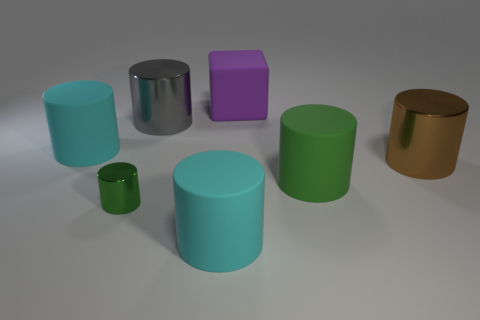Are there any other things that are the same color as the block?
Provide a succinct answer. No. How many green shiny cylinders have the same size as the gray cylinder?
Offer a terse response. 0. There is a object that is the same color as the tiny metal cylinder; what shape is it?
Provide a succinct answer. Cylinder. Do the big matte cylinder left of the tiny metal cylinder and the big shiny thing that is to the left of the large matte cube have the same color?
Provide a short and direct response. No. How many green rubber things are in front of the purple object?
Provide a succinct answer. 1. The cylinder that is the same color as the small object is what size?
Offer a very short reply. Large. Are there any other big purple things that have the same shape as the large purple thing?
Provide a succinct answer. No. What is the color of the other metal cylinder that is the same size as the brown cylinder?
Give a very brief answer. Gray. Is the number of big brown objects that are on the right side of the brown metal cylinder less than the number of cyan matte objects behind the gray shiny cylinder?
Your answer should be compact. No. Do the cyan matte cylinder that is behind the green metallic cylinder and the brown metal object have the same size?
Provide a succinct answer. Yes. 